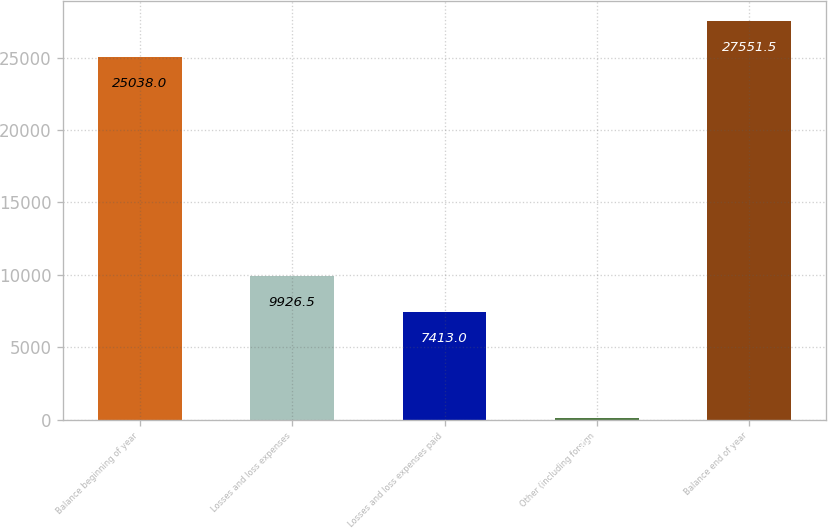Convert chart to OTSL. <chart><loc_0><loc_0><loc_500><loc_500><bar_chart><fcel>Balance beginning of year<fcel>Losses and loss expenses<fcel>Losses and loss expenses paid<fcel>Other (including foreign<fcel>Balance end of year<nl><fcel>25038<fcel>9926.5<fcel>7413<fcel>107<fcel>27551.5<nl></chart> 